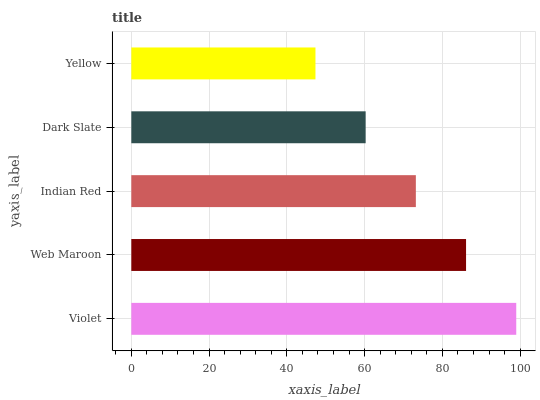Is Yellow the minimum?
Answer yes or no. Yes. Is Violet the maximum?
Answer yes or no. Yes. Is Web Maroon the minimum?
Answer yes or no. No. Is Web Maroon the maximum?
Answer yes or no. No. Is Violet greater than Web Maroon?
Answer yes or no. Yes. Is Web Maroon less than Violet?
Answer yes or no. Yes. Is Web Maroon greater than Violet?
Answer yes or no. No. Is Violet less than Web Maroon?
Answer yes or no. No. Is Indian Red the high median?
Answer yes or no. Yes. Is Indian Red the low median?
Answer yes or no. Yes. Is Web Maroon the high median?
Answer yes or no. No. Is Dark Slate the low median?
Answer yes or no. No. 